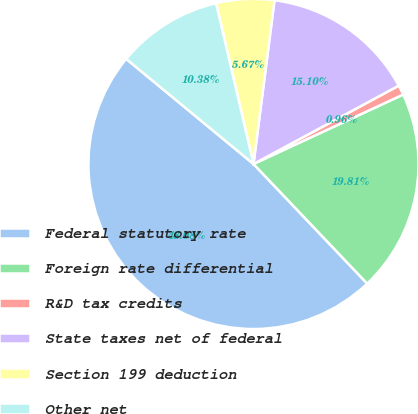<chart> <loc_0><loc_0><loc_500><loc_500><pie_chart><fcel>Federal statutory rate<fcel>Foreign rate differential<fcel>R&D tax credits<fcel>State taxes net of federal<fcel>Section 199 deduction<fcel>Other net<nl><fcel>48.08%<fcel>19.81%<fcel>0.96%<fcel>15.1%<fcel>5.67%<fcel>10.38%<nl></chart> 